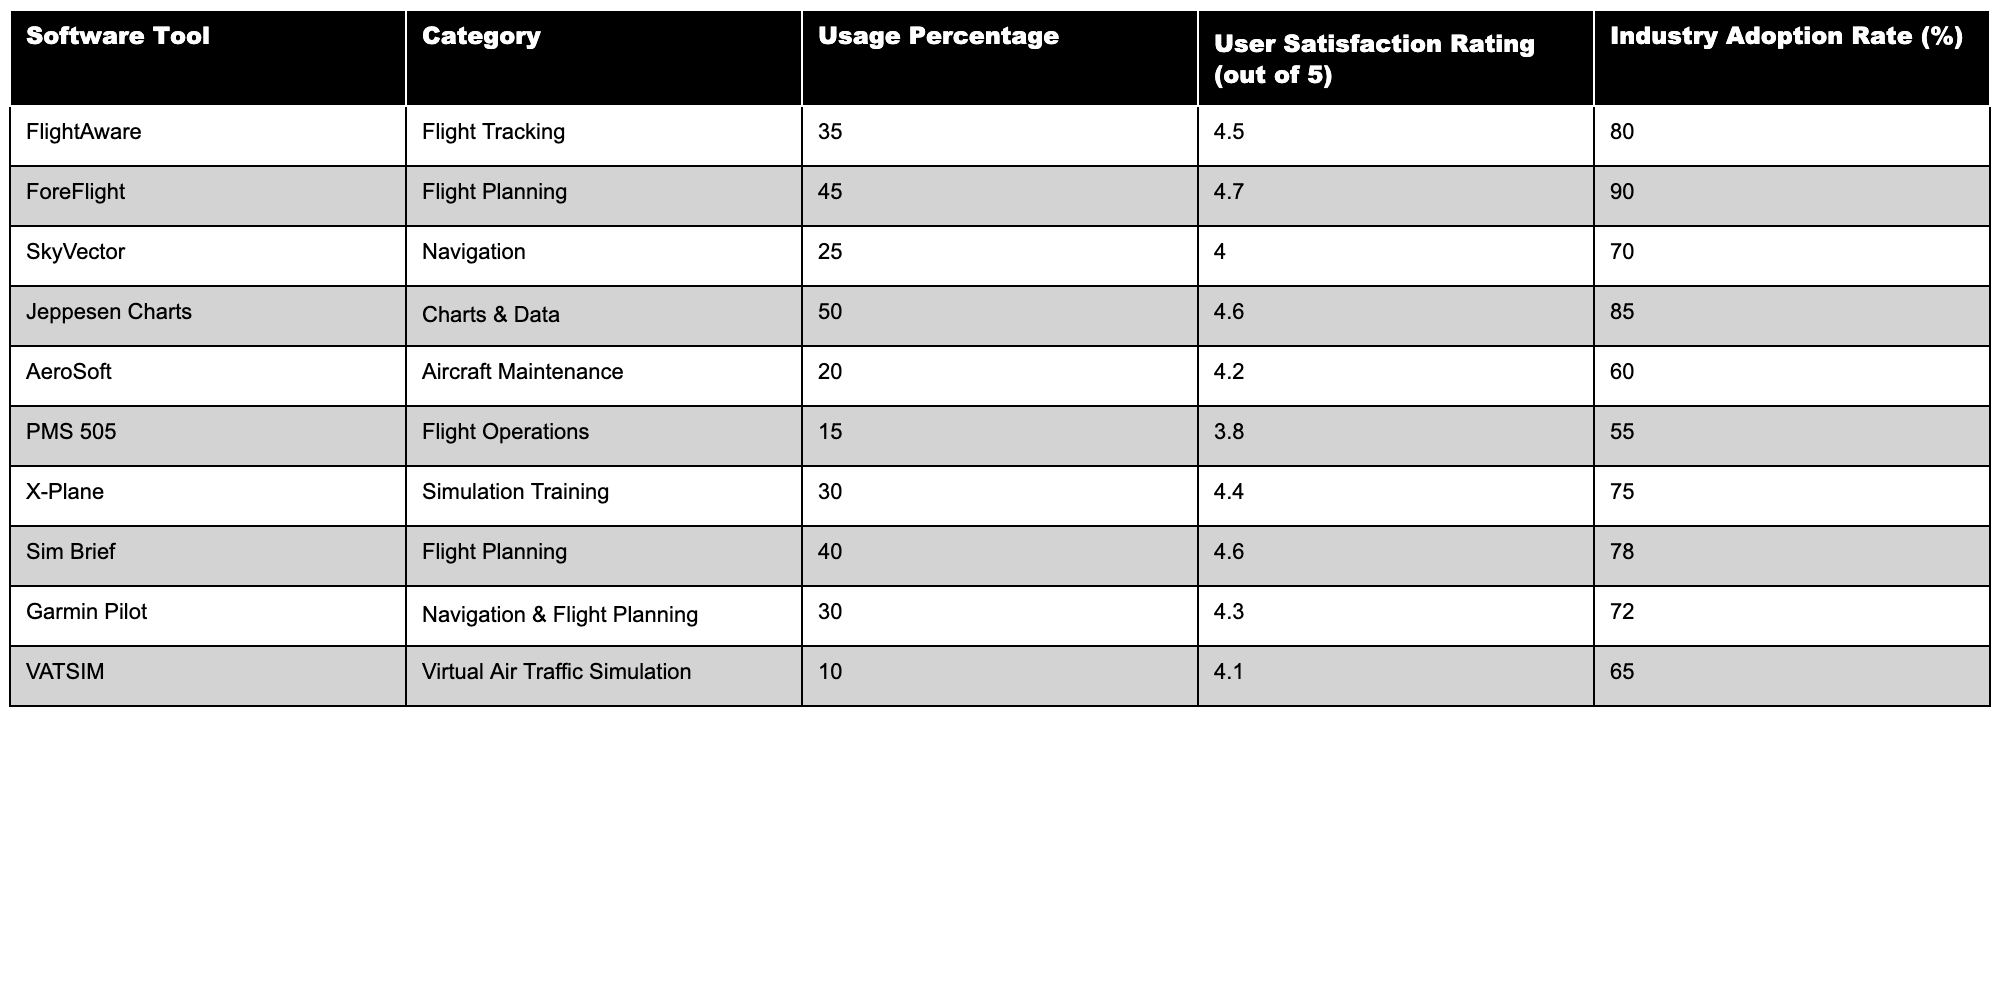What is the usage percentage of ForeFlight? The table shows that ForeFlight has a usage percentage of 45.
Answer: 45 Which software tool has the highest user satisfaction rating? Looking at the user satisfaction ratings, ForeFlight has the highest rating of 4.7.
Answer: ForeFlight What is the industry adoption rate for Jeppesen Charts? The industry adoption rate for Jeppesen Charts is listed as 85%.
Answer: 85% Which two software tools have a usage percentage greater than 40%? Reviewing the table, ForeFlight and Jeppesen Charts both have usage percentages of 45% and 50%, respectively.
Answer: ForeFlight and Jeppesen Charts Is the user satisfaction rating for SkyVector above 4.0? The user satisfaction rating for SkyVector is 4.0, which is not above 4.0.
Answer: No What is the difference in usage percentage between FlightAware and PMS 505? FlightAware has a usage percentage of 35%, while PMS 505 has 15%. The difference is 35 - 15 = 20.
Answer: 20 Calculate the average user satisfaction rating for all software tools listed. The user satisfaction ratings are 4.5, 4.7, 4.0, 4.6, 4.2, 3.8, 4.4, 4.6, 4.3, and 4.1. The sum is 46.2, and there are 10 tools, so the average is 46.2 / 10 = 4.62.
Answer: 4.62 Which software tool has the lowest industry adoption rate, and what is that rate? Observing the table, PMS 505 has the lowest industry adoption rate of 55%.
Answer: PMS 505, 55% Are there more tools in the Flight Planning category or in the Simulation Training category? There are two tools in Flight Planning (ForeFlight and Sim Brief) and one in Simulation Training (X-Plane), thus there are more in Flight Planning.
Answer: Flight Planning category If SkyVector's usage percentage increased by 10%, what would that new percentage be? SkyVector currently has a usage percentage of 25%. If it increases by 10%, the new percentage would be 25 + 10 = 35.
Answer: 35 